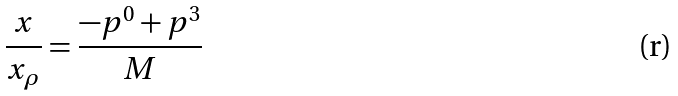<formula> <loc_0><loc_0><loc_500><loc_500>\frac { x } { x _ { \rho } } = \frac { - p ^ { 0 } + p ^ { 3 } } { M }</formula> 